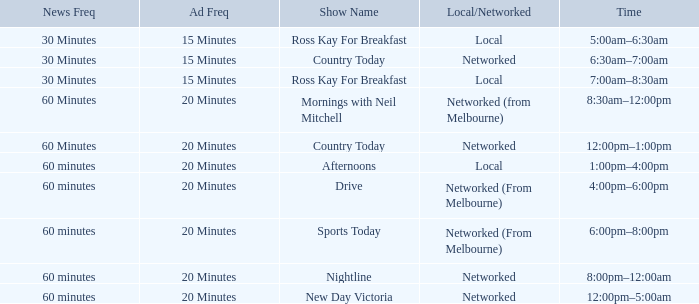What Local/Networked has a Show Name of nightline? Networked. 